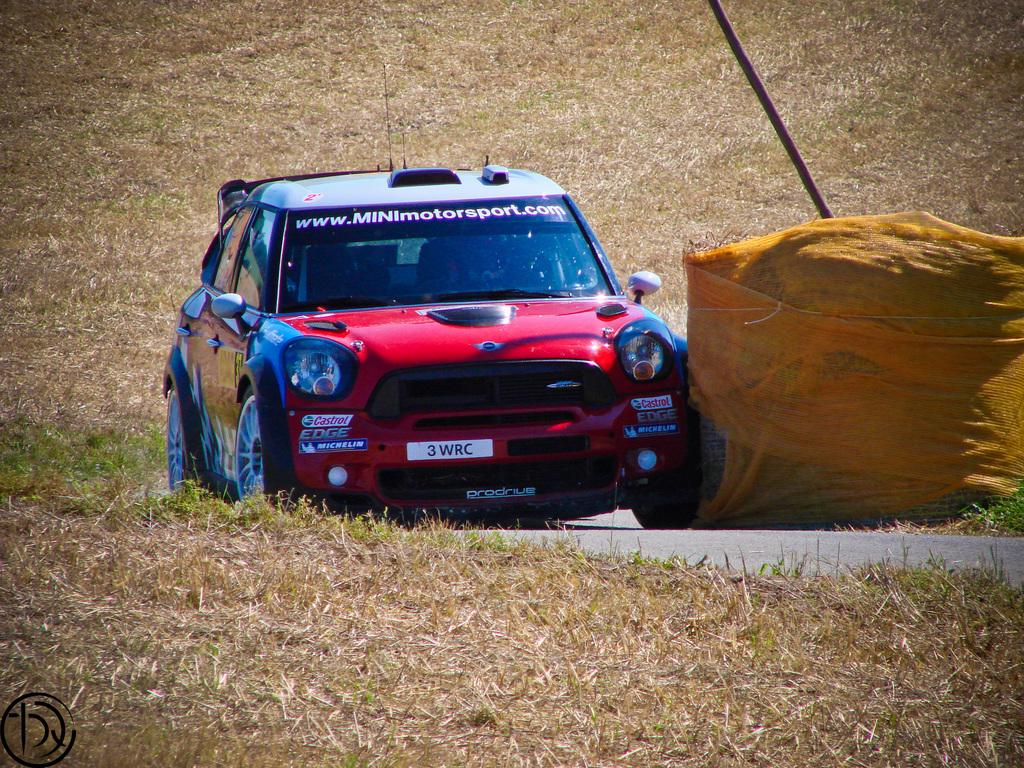What is the main subject of the image? There is a vehicle on a path in the image. Can you describe any other objects or features in the image? There is an object covered with a cloth beside the vehicle, and dry grass is present on the surface around the object. What type of pail is being used to write with a quill in the image? There is no pail or quill present in the image. 